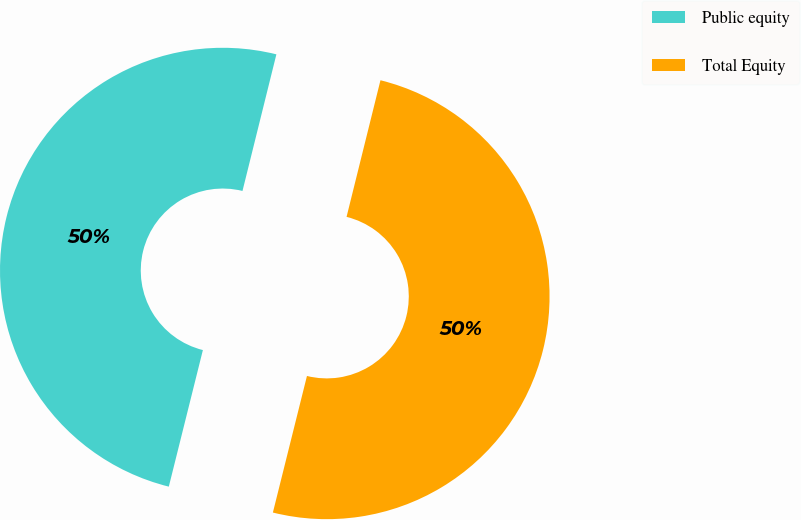Convert chart. <chart><loc_0><loc_0><loc_500><loc_500><pie_chart><fcel>Public equity<fcel>Total Equity<nl><fcel>49.98%<fcel>50.02%<nl></chart> 